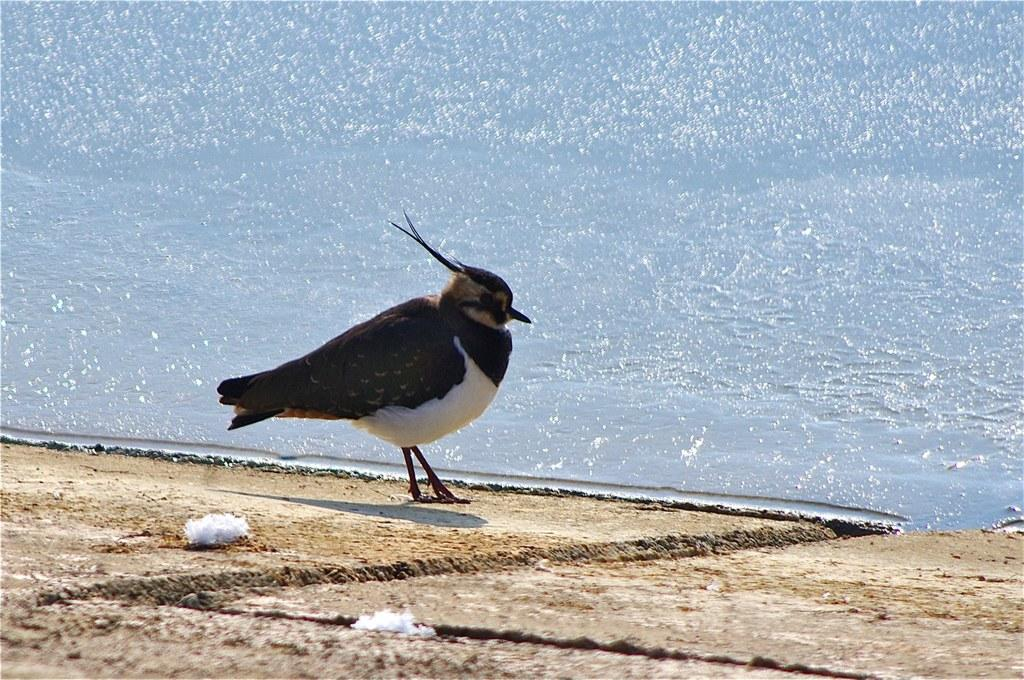What type of animal can be seen in the image? There is a bird in the image. Where is the bird located in the image? The bird is on the land. What else can be seen in the image besides the bird? There is water visible in the image. What type of chain is the bird wearing around its neck in the image? There is no chain visible around the bird's neck in the image. 